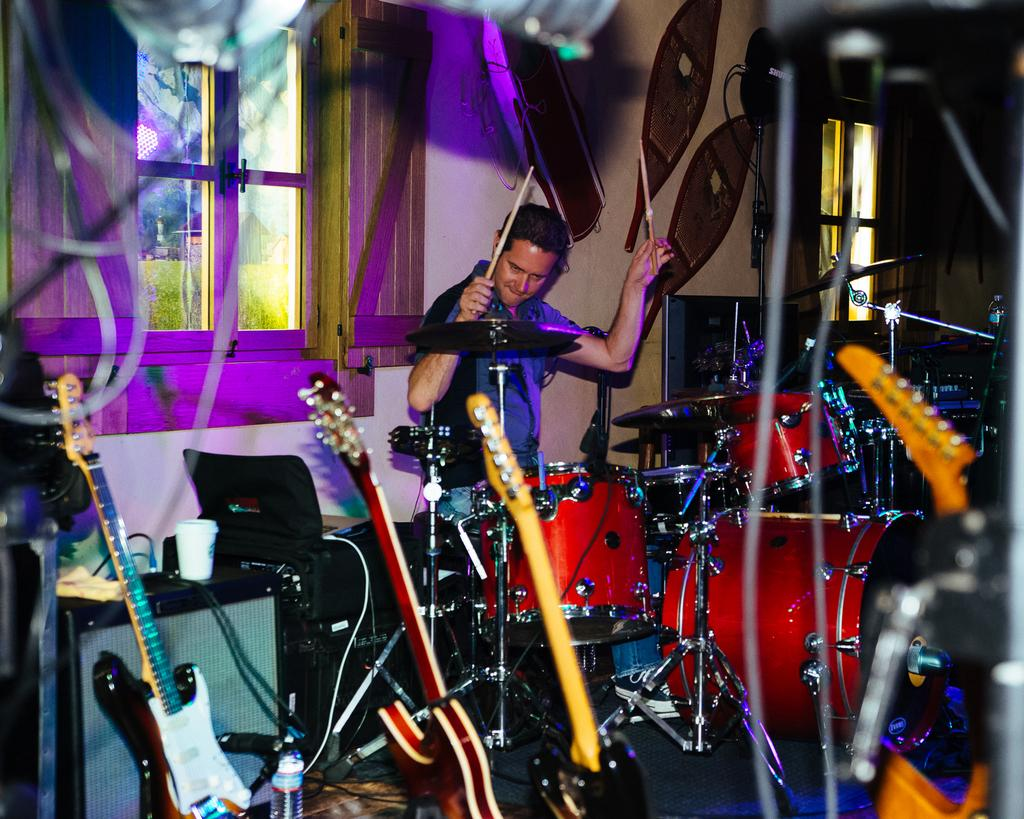What is the man in the image doing? The man is sitting next to a drum set. What musical instruments can be seen in the image? There are guitars in the image. What electronic device is present in the image? There is a laptop in the image. What is used for amplifying sound in the image? There is a speaker in the image. How much dirt can be seen on the guitars in the image? There is no dirt visible on the guitars in the image. What type of quill is being used to write on the laptop in the image? There is no quill present in the image; a laptop is used for typing or clicking, not writing with a quill. 